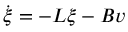<formula> <loc_0><loc_0><loc_500><loc_500>\dot { \xi } = - L \xi - B v</formula> 